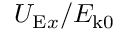Convert formula to latex. <formula><loc_0><loc_0><loc_500><loc_500>U _ { E x } / E _ { k 0 }</formula> 